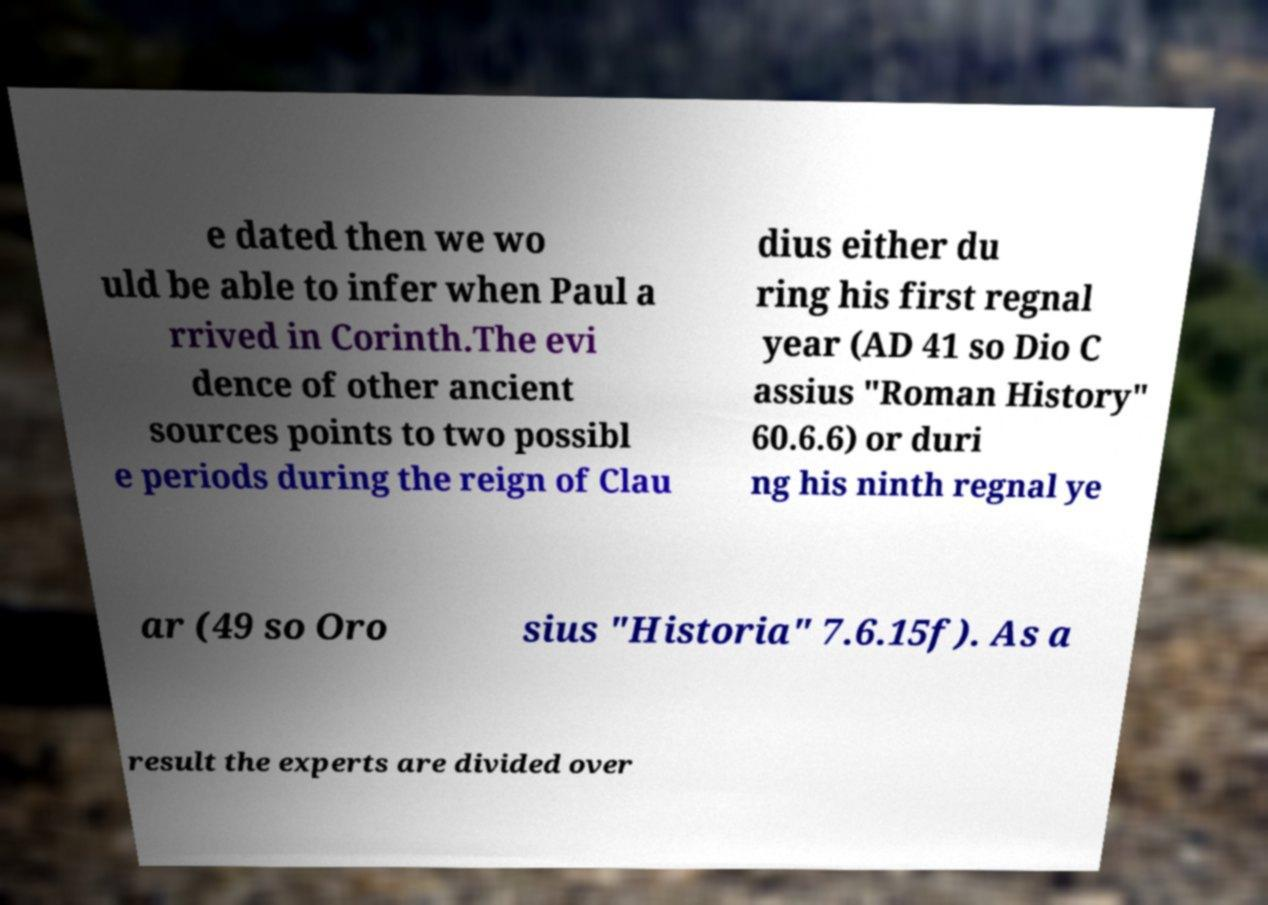Could you extract and type out the text from this image? e dated then we wo uld be able to infer when Paul a rrived in Corinth.The evi dence of other ancient sources points to two possibl e periods during the reign of Clau dius either du ring his first regnal year (AD 41 so Dio C assius "Roman History" 60.6.6) or duri ng his ninth regnal ye ar (49 so Oro sius "Historia" 7.6.15f). As a result the experts are divided over 